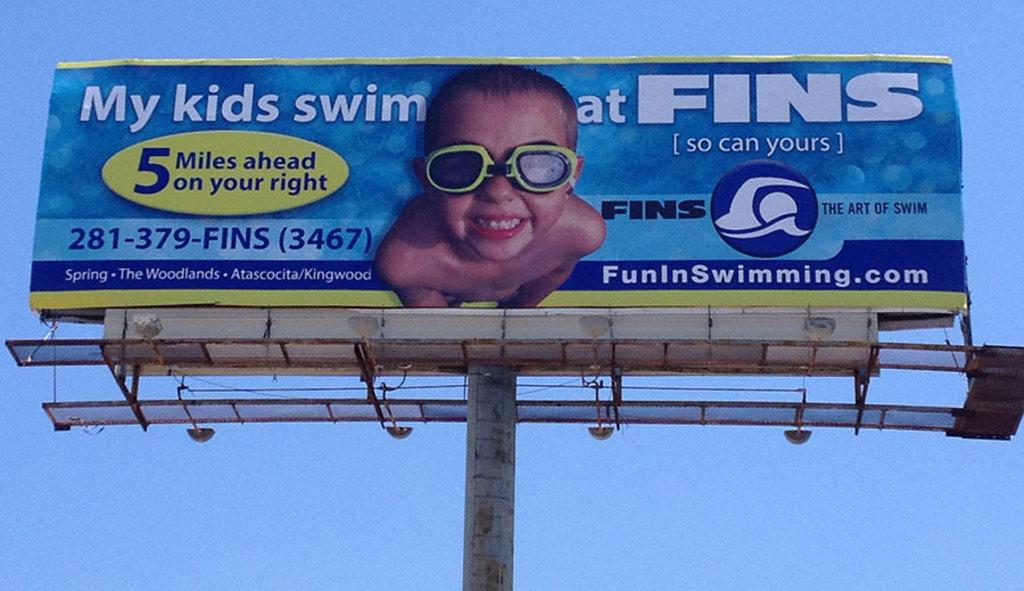How many more miles ahead is this place?
Provide a short and direct response. 5. 